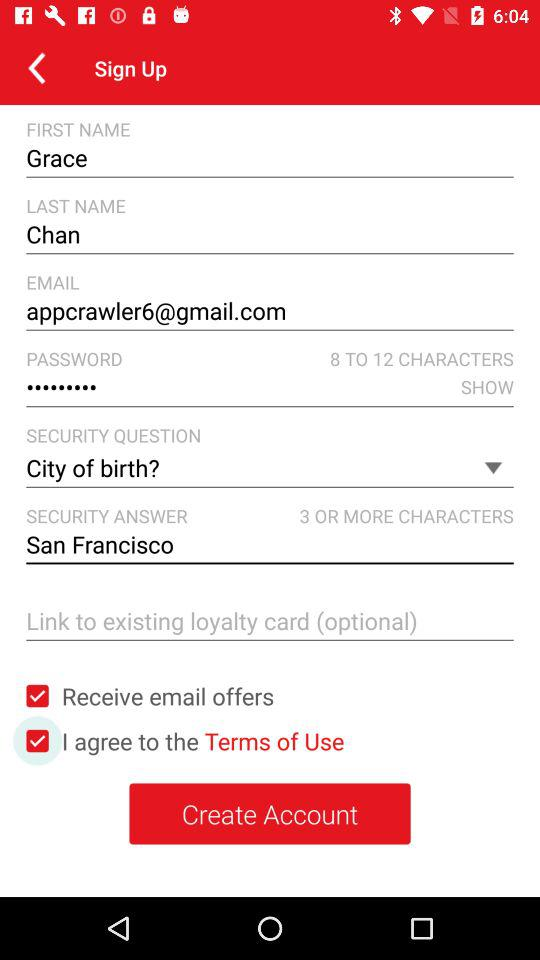What is the first name? The first name is Grace. 